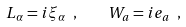Convert formula to latex. <formula><loc_0><loc_0><loc_500><loc_500>L _ { \alpha } = i \xi _ { \alpha } \ , \quad W _ { a } = i { e } _ { a } \ ,</formula> 